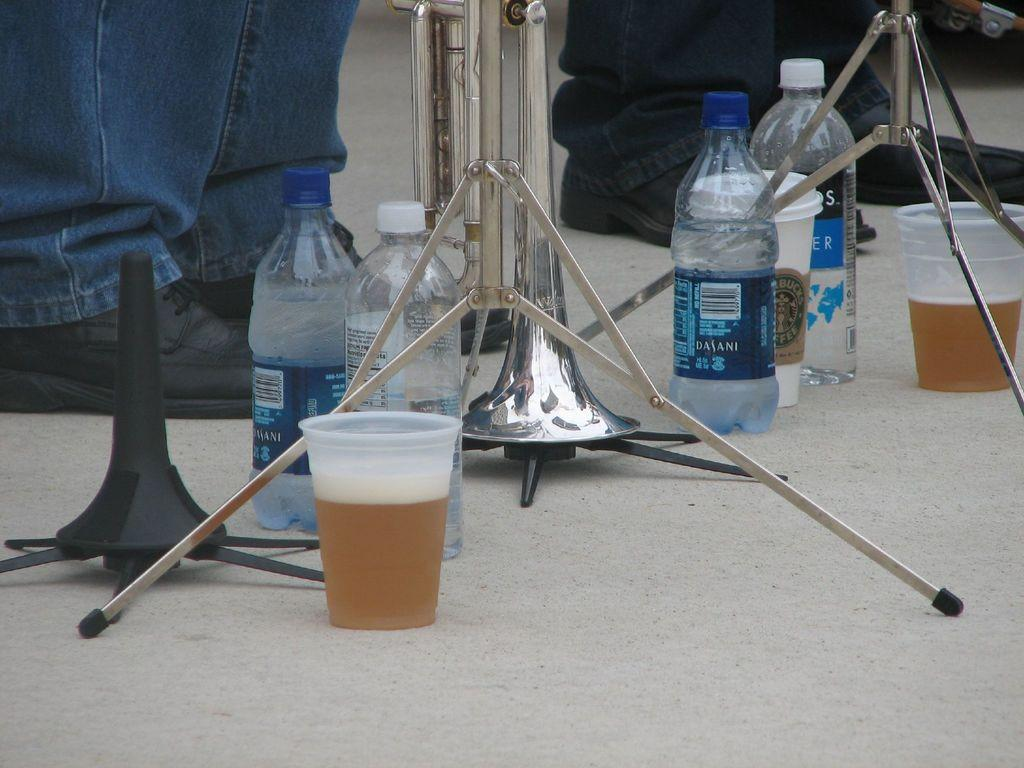<image>
Present a compact description of the photo's key features. A few cups of beer in plastic cups, some water bottles and starbucks coffee sitting on the ground. 